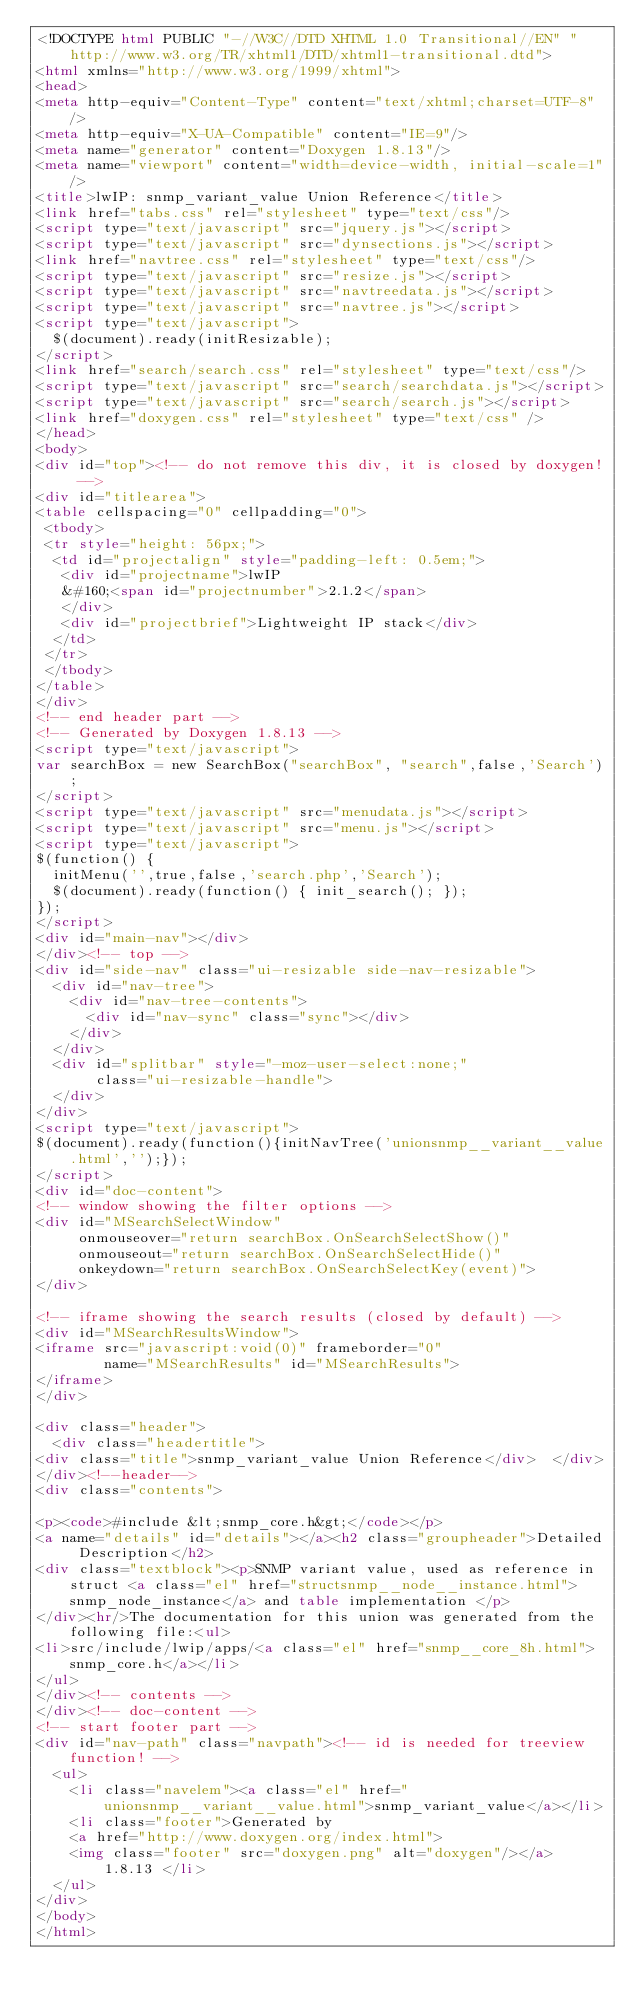Convert code to text. <code><loc_0><loc_0><loc_500><loc_500><_HTML_><!DOCTYPE html PUBLIC "-//W3C//DTD XHTML 1.0 Transitional//EN" "http://www.w3.org/TR/xhtml1/DTD/xhtml1-transitional.dtd">
<html xmlns="http://www.w3.org/1999/xhtml">
<head>
<meta http-equiv="Content-Type" content="text/xhtml;charset=UTF-8"/>
<meta http-equiv="X-UA-Compatible" content="IE=9"/>
<meta name="generator" content="Doxygen 1.8.13"/>
<meta name="viewport" content="width=device-width, initial-scale=1"/>
<title>lwIP: snmp_variant_value Union Reference</title>
<link href="tabs.css" rel="stylesheet" type="text/css"/>
<script type="text/javascript" src="jquery.js"></script>
<script type="text/javascript" src="dynsections.js"></script>
<link href="navtree.css" rel="stylesheet" type="text/css"/>
<script type="text/javascript" src="resize.js"></script>
<script type="text/javascript" src="navtreedata.js"></script>
<script type="text/javascript" src="navtree.js"></script>
<script type="text/javascript">
  $(document).ready(initResizable);
</script>
<link href="search/search.css" rel="stylesheet" type="text/css"/>
<script type="text/javascript" src="search/searchdata.js"></script>
<script type="text/javascript" src="search/search.js"></script>
<link href="doxygen.css" rel="stylesheet" type="text/css" />
</head>
<body>
<div id="top"><!-- do not remove this div, it is closed by doxygen! -->
<div id="titlearea">
<table cellspacing="0" cellpadding="0">
 <tbody>
 <tr style="height: 56px;">
  <td id="projectalign" style="padding-left: 0.5em;">
   <div id="projectname">lwIP
   &#160;<span id="projectnumber">2.1.2</span>
   </div>
   <div id="projectbrief">Lightweight IP stack</div>
  </td>
 </tr>
 </tbody>
</table>
</div>
<!-- end header part -->
<!-- Generated by Doxygen 1.8.13 -->
<script type="text/javascript">
var searchBox = new SearchBox("searchBox", "search",false,'Search');
</script>
<script type="text/javascript" src="menudata.js"></script>
<script type="text/javascript" src="menu.js"></script>
<script type="text/javascript">
$(function() {
  initMenu('',true,false,'search.php','Search');
  $(document).ready(function() { init_search(); });
});
</script>
<div id="main-nav"></div>
</div><!-- top -->
<div id="side-nav" class="ui-resizable side-nav-resizable">
  <div id="nav-tree">
    <div id="nav-tree-contents">
      <div id="nav-sync" class="sync"></div>
    </div>
  </div>
  <div id="splitbar" style="-moz-user-select:none;" 
       class="ui-resizable-handle">
  </div>
</div>
<script type="text/javascript">
$(document).ready(function(){initNavTree('unionsnmp__variant__value.html','');});
</script>
<div id="doc-content">
<!-- window showing the filter options -->
<div id="MSearchSelectWindow"
     onmouseover="return searchBox.OnSearchSelectShow()"
     onmouseout="return searchBox.OnSearchSelectHide()"
     onkeydown="return searchBox.OnSearchSelectKey(event)">
</div>

<!-- iframe showing the search results (closed by default) -->
<div id="MSearchResultsWindow">
<iframe src="javascript:void(0)" frameborder="0" 
        name="MSearchResults" id="MSearchResults">
</iframe>
</div>

<div class="header">
  <div class="headertitle">
<div class="title">snmp_variant_value Union Reference</div>  </div>
</div><!--header-->
<div class="contents">

<p><code>#include &lt;snmp_core.h&gt;</code></p>
<a name="details" id="details"></a><h2 class="groupheader">Detailed Description</h2>
<div class="textblock"><p>SNMP variant value, used as reference in struct <a class="el" href="structsnmp__node__instance.html">snmp_node_instance</a> and table implementation </p>
</div><hr/>The documentation for this union was generated from the following file:<ul>
<li>src/include/lwip/apps/<a class="el" href="snmp__core_8h.html">snmp_core.h</a></li>
</ul>
</div><!-- contents -->
</div><!-- doc-content -->
<!-- start footer part -->
<div id="nav-path" class="navpath"><!-- id is needed for treeview function! -->
  <ul>
    <li class="navelem"><a class="el" href="unionsnmp__variant__value.html">snmp_variant_value</a></li>
    <li class="footer">Generated by
    <a href="http://www.doxygen.org/index.html">
    <img class="footer" src="doxygen.png" alt="doxygen"/></a> 1.8.13 </li>
  </ul>
</div>
</body>
</html>
</code> 